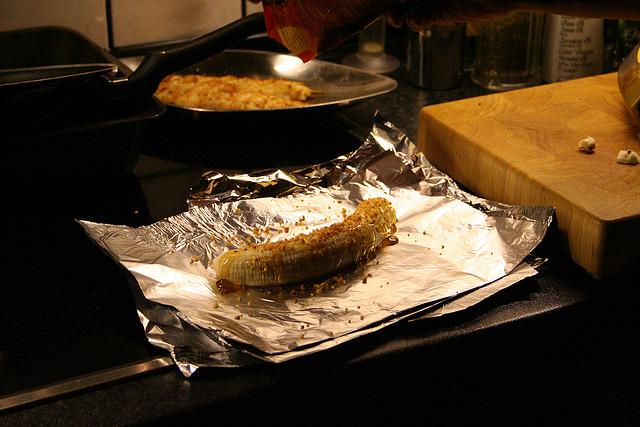Is this in a kitchen?
Answer briefly. Yes. What is being cooked on the foil?
Give a very brief answer. Banana. How many sheets of tinfoil are there?
Quick response, please. 3. 